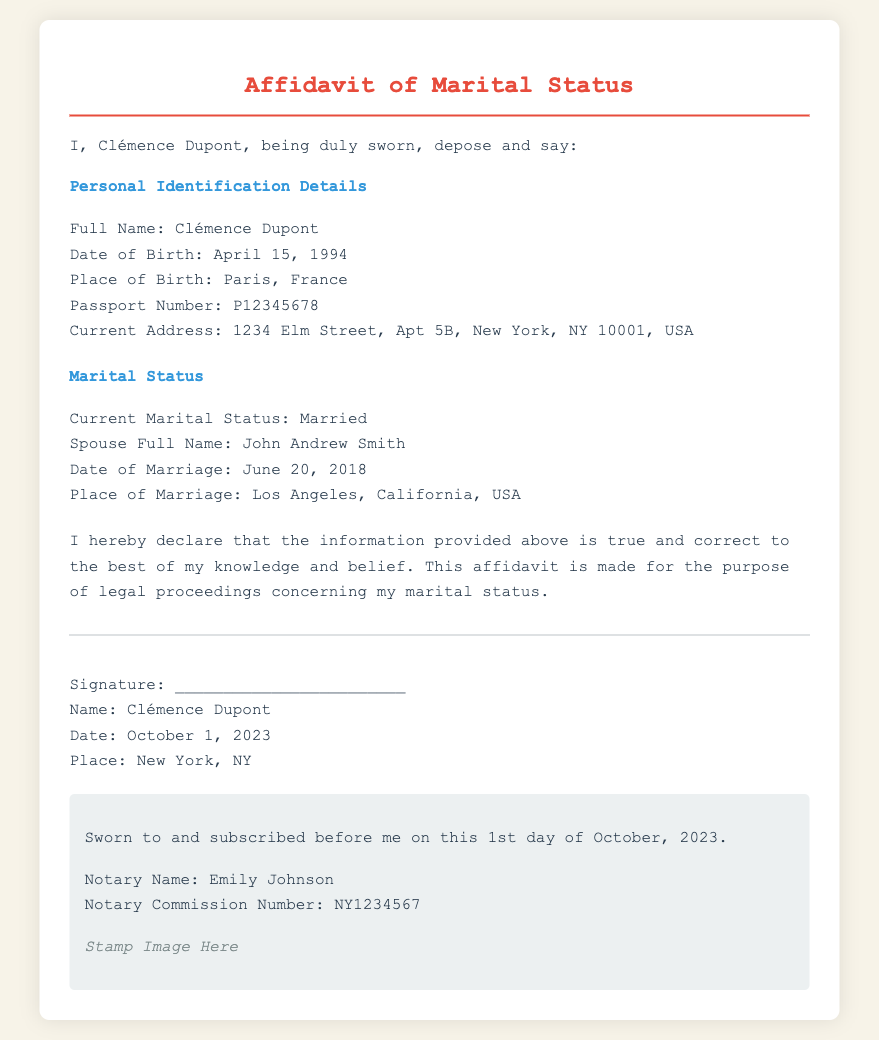What is the full name of the affiant? The affiant's full name is mentioned at the beginning of the affidavit.
Answer: Clémence Dupont What is the date of birth of Clémence Dupont? The date of birth is specified in the personal identification details section of the affidavit.
Answer: April 15, 1994 Where was Clémence Dupont born? The place of birth is documented in the personal identification section.
Answer: Paris, France What is Clémence Dupont's current marital status? The marital status is stated in the marital status section of the document.
Answer: Married When was Clémence Dupont married? The date of marriage can be found in the marital status section.
Answer: June 20, 2018 Where did Clémence Dupont's marriage take place? The place of marriage is specified in the marital status section of the document.
Answer: Los Angeles, California, USA Who notarized the affidavit? The name of the notary is provided in the notary section of the document.
Answer: Emily Johnson What is the notary commission number? The commission number for the notary is listed in the document.
Answer: NY1234567 On what date was the affidavit sworn? The date of the affidavit being sworn is mentioned in the notary section.
Answer: October 1, 2023 